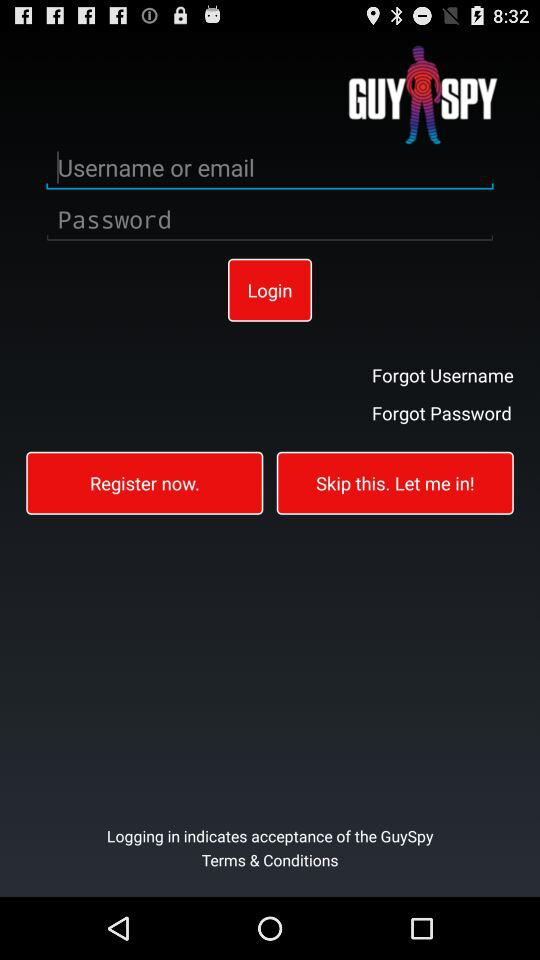What is the application name? The application name is "GUYSPY". 